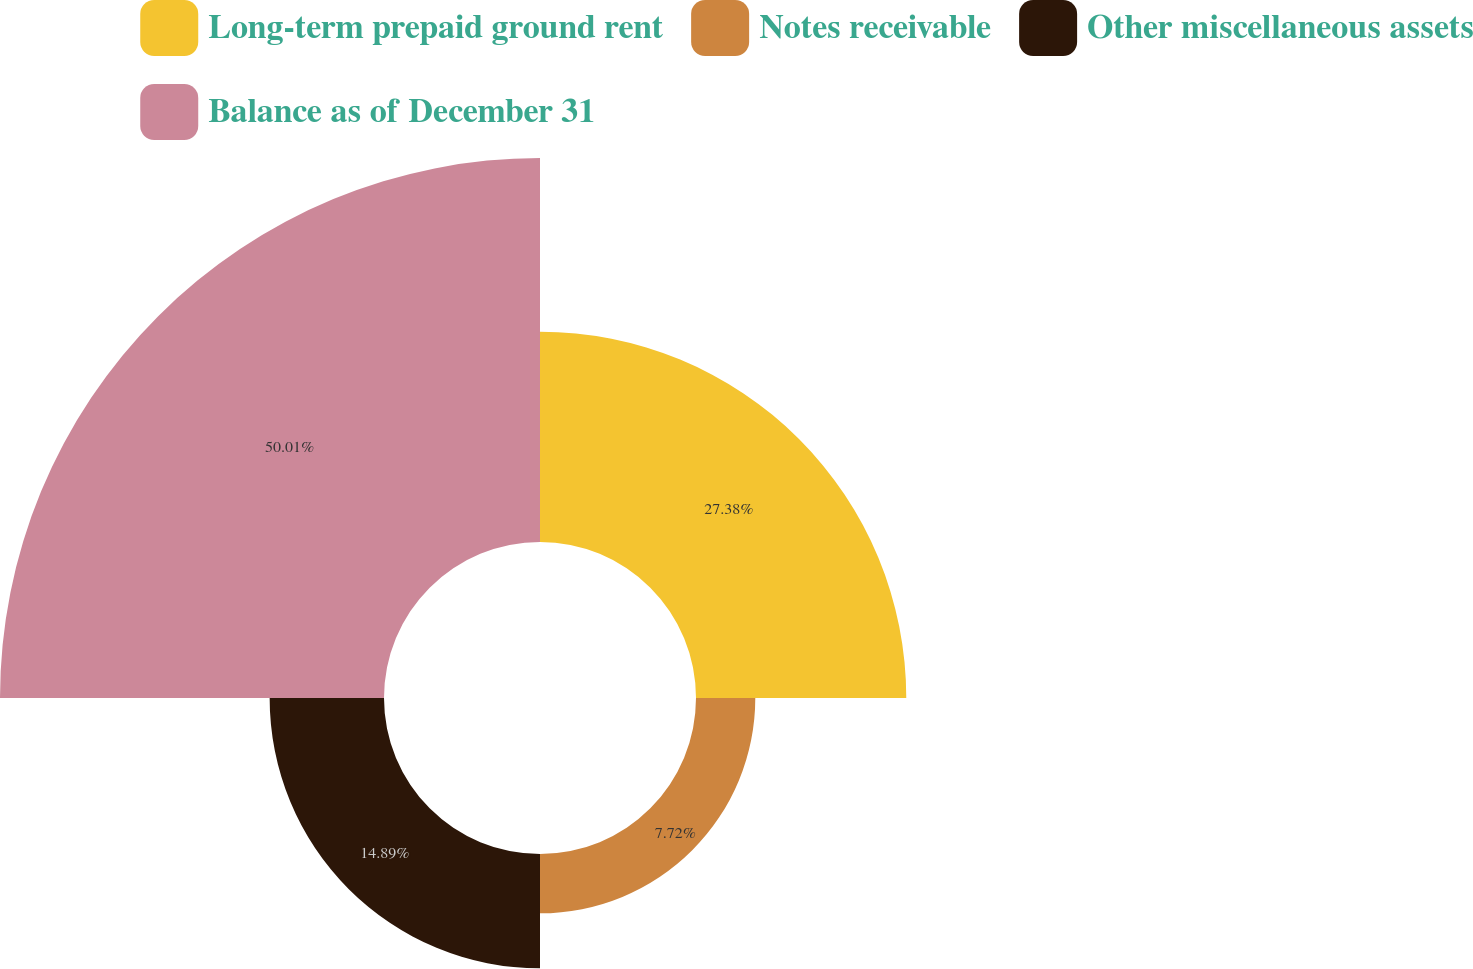Convert chart to OTSL. <chart><loc_0><loc_0><loc_500><loc_500><pie_chart><fcel>Long-term prepaid ground rent<fcel>Notes receivable<fcel>Other miscellaneous assets<fcel>Balance as of December 31<nl><fcel>27.38%<fcel>7.72%<fcel>14.89%<fcel>50.0%<nl></chart> 